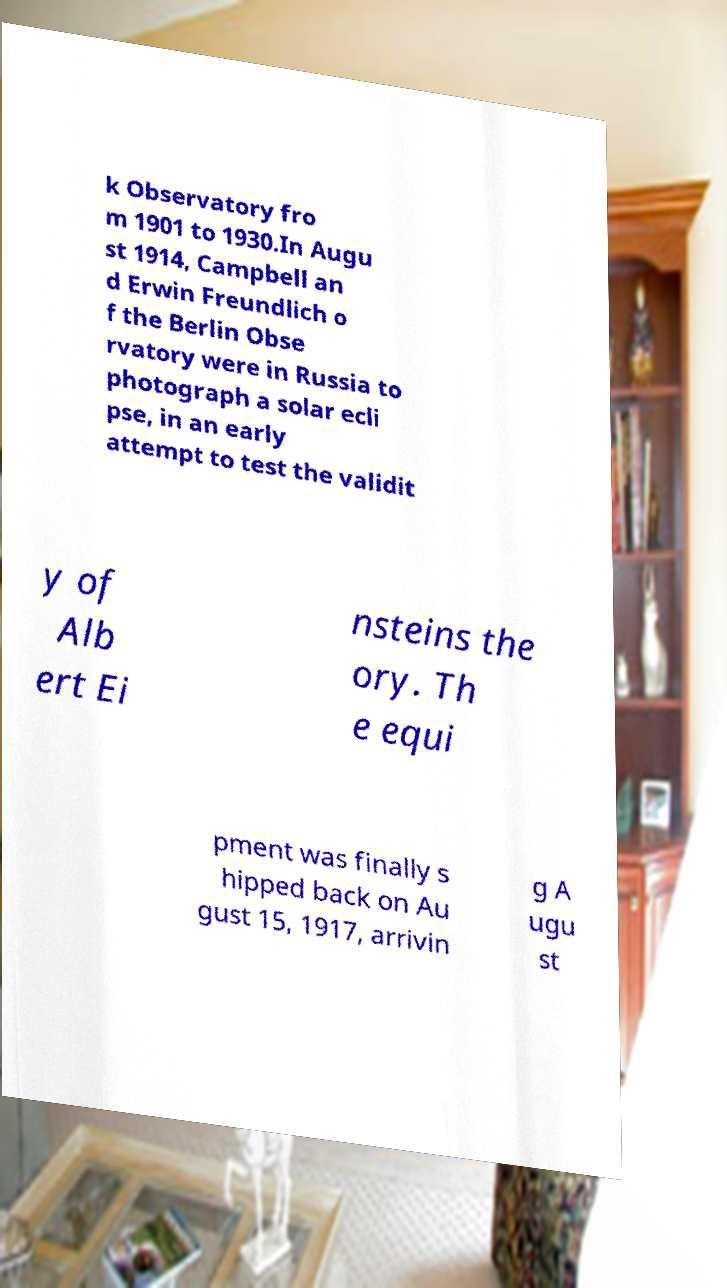Could you extract and type out the text from this image? k Observatory fro m 1901 to 1930.In Augu st 1914, Campbell an d Erwin Freundlich o f the Berlin Obse rvatory were in Russia to photograph a solar ecli pse, in an early attempt to test the validit y of Alb ert Ei nsteins the ory. Th e equi pment was finally s hipped back on Au gust 15, 1917, arrivin g A ugu st 